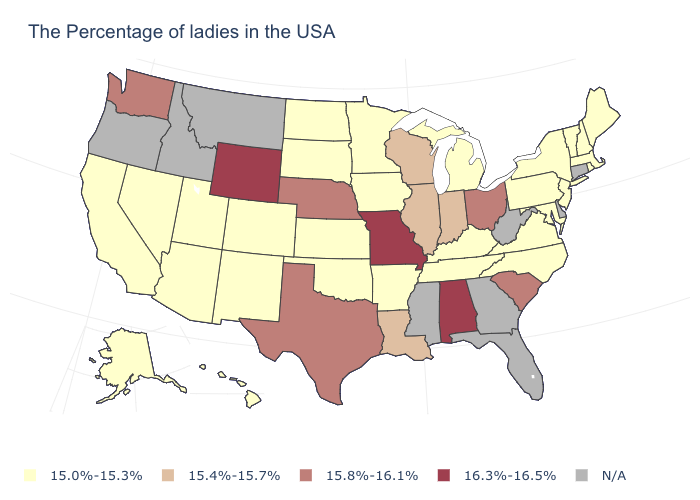What is the highest value in the MidWest ?
Quick response, please. 16.3%-16.5%. What is the value of Arkansas?
Be succinct. 15.0%-15.3%. Name the states that have a value in the range 15.0%-15.3%?
Be succinct. Maine, Massachusetts, Rhode Island, New Hampshire, Vermont, New York, New Jersey, Maryland, Pennsylvania, Virginia, North Carolina, Michigan, Kentucky, Tennessee, Arkansas, Minnesota, Iowa, Kansas, Oklahoma, South Dakota, North Dakota, Colorado, New Mexico, Utah, Arizona, Nevada, California, Alaska, Hawaii. Name the states that have a value in the range 15.4%-15.7%?
Answer briefly. Indiana, Wisconsin, Illinois, Louisiana. Among the states that border Missouri , does Arkansas have the lowest value?
Write a very short answer. Yes. Which states have the lowest value in the West?
Short answer required. Colorado, New Mexico, Utah, Arizona, Nevada, California, Alaska, Hawaii. Name the states that have a value in the range 15.8%-16.1%?
Short answer required. South Carolina, Ohio, Nebraska, Texas, Washington. What is the value of Virginia?
Concise answer only. 15.0%-15.3%. Name the states that have a value in the range 15.0%-15.3%?
Answer briefly. Maine, Massachusetts, Rhode Island, New Hampshire, Vermont, New York, New Jersey, Maryland, Pennsylvania, Virginia, North Carolina, Michigan, Kentucky, Tennessee, Arkansas, Minnesota, Iowa, Kansas, Oklahoma, South Dakota, North Dakota, Colorado, New Mexico, Utah, Arizona, Nevada, California, Alaska, Hawaii. Among the states that border Oregon , does Washington have the highest value?
Write a very short answer. Yes. What is the lowest value in the USA?
Answer briefly. 15.0%-15.3%. What is the value of Connecticut?
Concise answer only. N/A. What is the lowest value in the Northeast?
Be succinct. 15.0%-15.3%. 